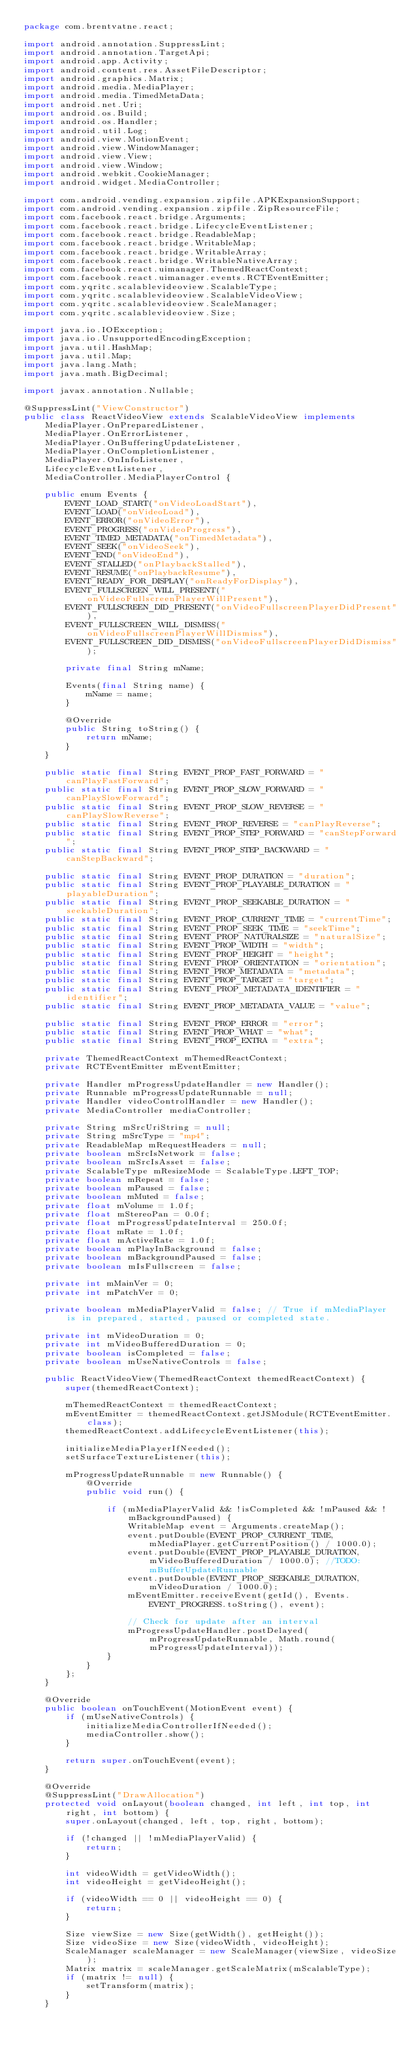<code> <loc_0><loc_0><loc_500><loc_500><_Java_>package com.brentvatne.react;

import android.annotation.SuppressLint;
import android.annotation.TargetApi;
import android.app.Activity;
import android.content.res.AssetFileDescriptor;
import android.graphics.Matrix;
import android.media.MediaPlayer;
import android.media.TimedMetaData;
import android.net.Uri;
import android.os.Build;
import android.os.Handler;
import android.util.Log;
import android.view.MotionEvent;
import android.view.WindowManager;
import android.view.View;
import android.view.Window;
import android.webkit.CookieManager;
import android.widget.MediaController;

import com.android.vending.expansion.zipfile.APKExpansionSupport;
import com.android.vending.expansion.zipfile.ZipResourceFile;
import com.facebook.react.bridge.Arguments;
import com.facebook.react.bridge.LifecycleEventListener;
import com.facebook.react.bridge.ReadableMap;
import com.facebook.react.bridge.WritableMap;
import com.facebook.react.bridge.WritableArray;
import com.facebook.react.bridge.WritableNativeArray;
import com.facebook.react.uimanager.ThemedReactContext;
import com.facebook.react.uimanager.events.RCTEventEmitter;
import com.yqritc.scalablevideoview.ScalableType;
import com.yqritc.scalablevideoview.ScalableVideoView;
import com.yqritc.scalablevideoview.ScaleManager;
import com.yqritc.scalablevideoview.Size;

import java.io.IOException;
import java.io.UnsupportedEncodingException;
import java.util.HashMap;
import java.util.Map;
import java.lang.Math;
import java.math.BigDecimal;

import javax.annotation.Nullable;

@SuppressLint("ViewConstructor")
public class ReactVideoView extends ScalableVideoView implements
    MediaPlayer.OnPreparedListener,
    MediaPlayer.OnErrorListener,
    MediaPlayer.OnBufferingUpdateListener,
    MediaPlayer.OnCompletionListener,
    MediaPlayer.OnInfoListener,
    LifecycleEventListener,
    MediaController.MediaPlayerControl {

    public enum Events {
        EVENT_LOAD_START("onVideoLoadStart"),
        EVENT_LOAD("onVideoLoad"),
        EVENT_ERROR("onVideoError"),
        EVENT_PROGRESS("onVideoProgress"),
        EVENT_TIMED_METADATA("onTimedMetadata"),
        EVENT_SEEK("onVideoSeek"),
        EVENT_END("onVideoEnd"),
        EVENT_STALLED("onPlaybackStalled"),
        EVENT_RESUME("onPlaybackResume"),
        EVENT_READY_FOR_DISPLAY("onReadyForDisplay"),
        EVENT_FULLSCREEN_WILL_PRESENT("onVideoFullscreenPlayerWillPresent"),
        EVENT_FULLSCREEN_DID_PRESENT("onVideoFullscreenPlayerDidPresent"),
        EVENT_FULLSCREEN_WILL_DISMISS("onVideoFullscreenPlayerWillDismiss"),
        EVENT_FULLSCREEN_DID_DISMISS("onVideoFullscreenPlayerDidDismiss");

        private final String mName;

        Events(final String name) {
            mName = name;
        }

        @Override
        public String toString() {
            return mName;
        }
    }

    public static final String EVENT_PROP_FAST_FORWARD = "canPlayFastForward";
    public static final String EVENT_PROP_SLOW_FORWARD = "canPlaySlowForward";
    public static final String EVENT_PROP_SLOW_REVERSE = "canPlaySlowReverse";
    public static final String EVENT_PROP_REVERSE = "canPlayReverse";
    public static final String EVENT_PROP_STEP_FORWARD = "canStepForward";
    public static final String EVENT_PROP_STEP_BACKWARD = "canStepBackward";

    public static final String EVENT_PROP_DURATION = "duration";
    public static final String EVENT_PROP_PLAYABLE_DURATION = "playableDuration";
    public static final String EVENT_PROP_SEEKABLE_DURATION = "seekableDuration";
    public static final String EVENT_PROP_CURRENT_TIME = "currentTime";
    public static final String EVENT_PROP_SEEK_TIME = "seekTime";
    public static final String EVENT_PROP_NATURALSIZE = "naturalSize";
    public static final String EVENT_PROP_WIDTH = "width";
    public static final String EVENT_PROP_HEIGHT = "height";
    public static final String EVENT_PROP_ORIENTATION = "orientation";
    public static final String EVENT_PROP_METADATA = "metadata";
    public static final String EVENT_PROP_TARGET = "target";
    public static final String EVENT_PROP_METADATA_IDENTIFIER = "identifier";
    public static final String EVENT_PROP_METADATA_VALUE = "value";

    public static final String EVENT_PROP_ERROR = "error";
    public static final String EVENT_PROP_WHAT = "what";
    public static final String EVENT_PROP_EXTRA = "extra";

    private ThemedReactContext mThemedReactContext;
    private RCTEventEmitter mEventEmitter;

    private Handler mProgressUpdateHandler = new Handler();
    private Runnable mProgressUpdateRunnable = null;
    private Handler videoControlHandler = new Handler();
    private MediaController mediaController;

    private String mSrcUriString = null;
    private String mSrcType = "mp4";
    private ReadableMap mRequestHeaders = null;
    private boolean mSrcIsNetwork = false;
    private boolean mSrcIsAsset = false;
    private ScalableType mResizeMode = ScalableType.LEFT_TOP;
    private boolean mRepeat = false;
    private boolean mPaused = false;
    private boolean mMuted = false;
    private float mVolume = 1.0f;
    private float mStereoPan = 0.0f;
    private float mProgressUpdateInterval = 250.0f;
    private float mRate = 1.0f;
    private float mActiveRate = 1.0f;
    private boolean mPlayInBackground = false;
    private boolean mBackgroundPaused = false;
    private boolean mIsFullscreen = false;

    private int mMainVer = 0;
    private int mPatchVer = 0;

    private boolean mMediaPlayerValid = false; // True if mMediaPlayer is in prepared, started, paused or completed state.

    private int mVideoDuration = 0;
    private int mVideoBufferedDuration = 0;
    private boolean isCompleted = false;
    private boolean mUseNativeControls = false;

    public ReactVideoView(ThemedReactContext themedReactContext) {
        super(themedReactContext);

        mThemedReactContext = themedReactContext;
        mEventEmitter = themedReactContext.getJSModule(RCTEventEmitter.class);
        themedReactContext.addLifecycleEventListener(this);

        initializeMediaPlayerIfNeeded();
        setSurfaceTextureListener(this);

        mProgressUpdateRunnable = new Runnable() {
            @Override
            public void run() {

                if (mMediaPlayerValid && !isCompleted && !mPaused && !mBackgroundPaused) {
                    WritableMap event = Arguments.createMap();
                    event.putDouble(EVENT_PROP_CURRENT_TIME, mMediaPlayer.getCurrentPosition() / 1000.0);
                    event.putDouble(EVENT_PROP_PLAYABLE_DURATION, mVideoBufferedDuration / 1000.0); //TODO:mBufferUpdateRunnable
                    event.putDouble(EVENT_PROP_SEEKABLE_DURATION, mVideoDuration / 1000.0);
                    mEventEmitter.receiveEvent(getId(), Events.EVENT_PROGRESS.toString(), event);

                    // Check for update after an interval
                    mProgressUpdateHandler.postDelayed(mProgressUpdateRunnable, Math.round(mProgressUpdateInterval));
                }
            }
        };
    }

    @Override
    public boolean onTouchEvent(MotionEvent event) {
        if (mUseNativeControls) {
            initializeMediaControllerIfNeeded();
            mediaController.show();
        }

        return super.onTouchEvent(event);
    }

    @Override
    @SuppressLint("DrawAllocation")
    protected void onLayout(boolean changed, int left, int top, int right, int bottom) {
        super.onLayout(changed, left, top, right, bottom);

        if (!changed || !mMediaPlayerValid) {
            return;
        }

        int videoWidth = getVideoWidth();
        int videoHeight = getVideoHeight();

        if (videoWidth == 0 || videoHeight == 0) {
            return;
        }

        Size viewSize = new Size(getWidth(), getHeight());
        Size videoSize = new Size(videoWidth, videoHeight);
        ScaleManager scaleManager = new ScaleManager(viewSize, videoSize);
        Matrix matrix = scaleManager.getScaleMatrix(mScalableType);
        if (matrix != null) {
            setTransform(matrix);
        }
    }
</code> 